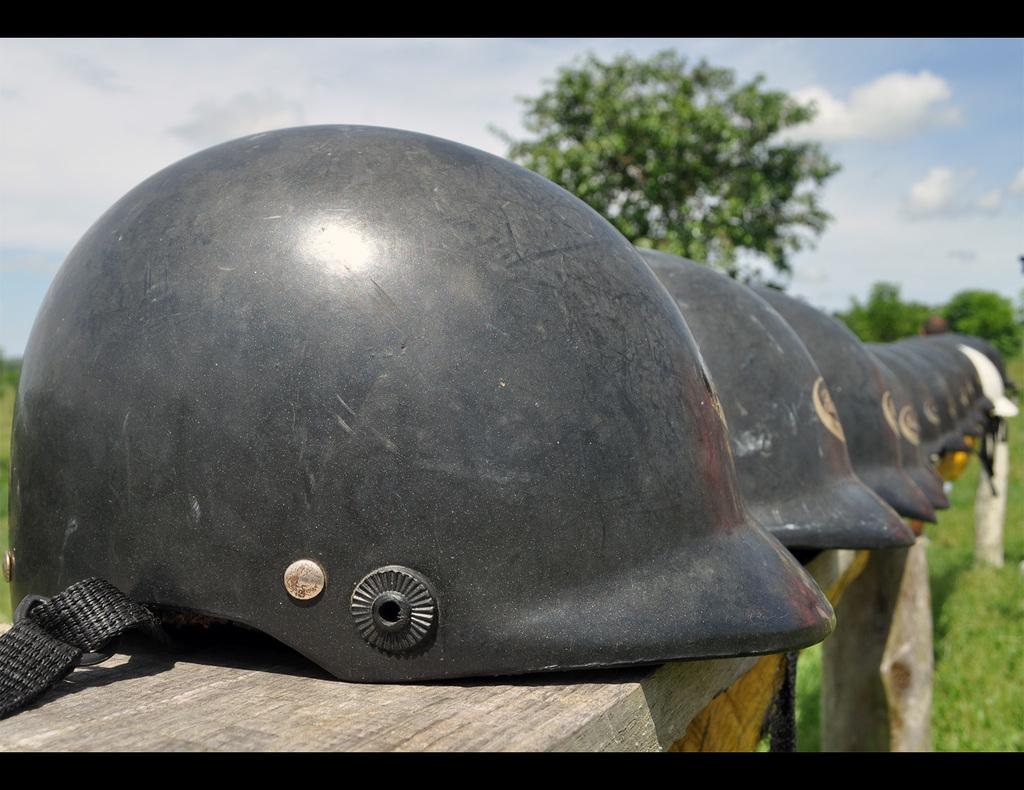What objects are hanging on the wooden rack in the image? There are helmets on a wooden rack in the image. What type of vegetation can be seen on the right side of the image? There is green grass on the right side of the image. What can be seen in the background of the image? There are trees visible in the background of the image. What is visible at the top of the image? The sky is visible at the top of the image. What is the condition of the sky in the image? Clouds are present in the sky. Where is the playground located in the image? There is no playground present in the image. What type of house is visible in the image? There is no house visible in the image. 